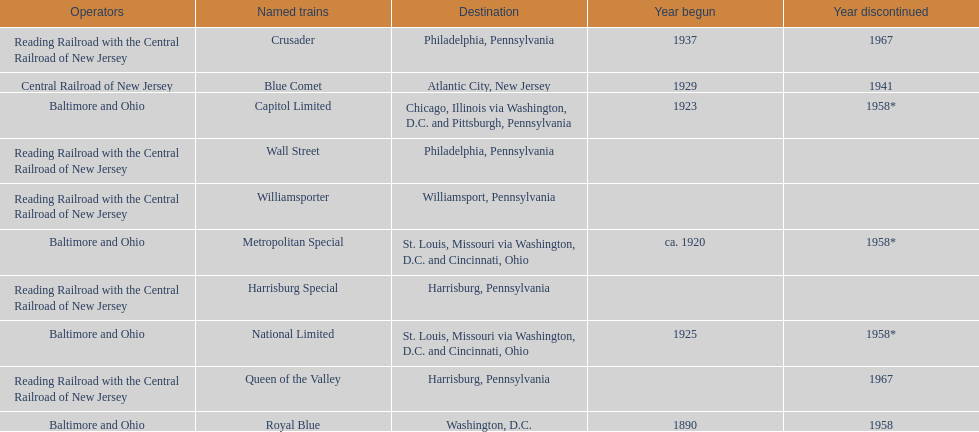Which train ran for the longest time? Royal Blue. 